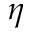Convert formula to latex. <formula><loc_0><loc_0><loc_500><loc_500>\eta</formula> 